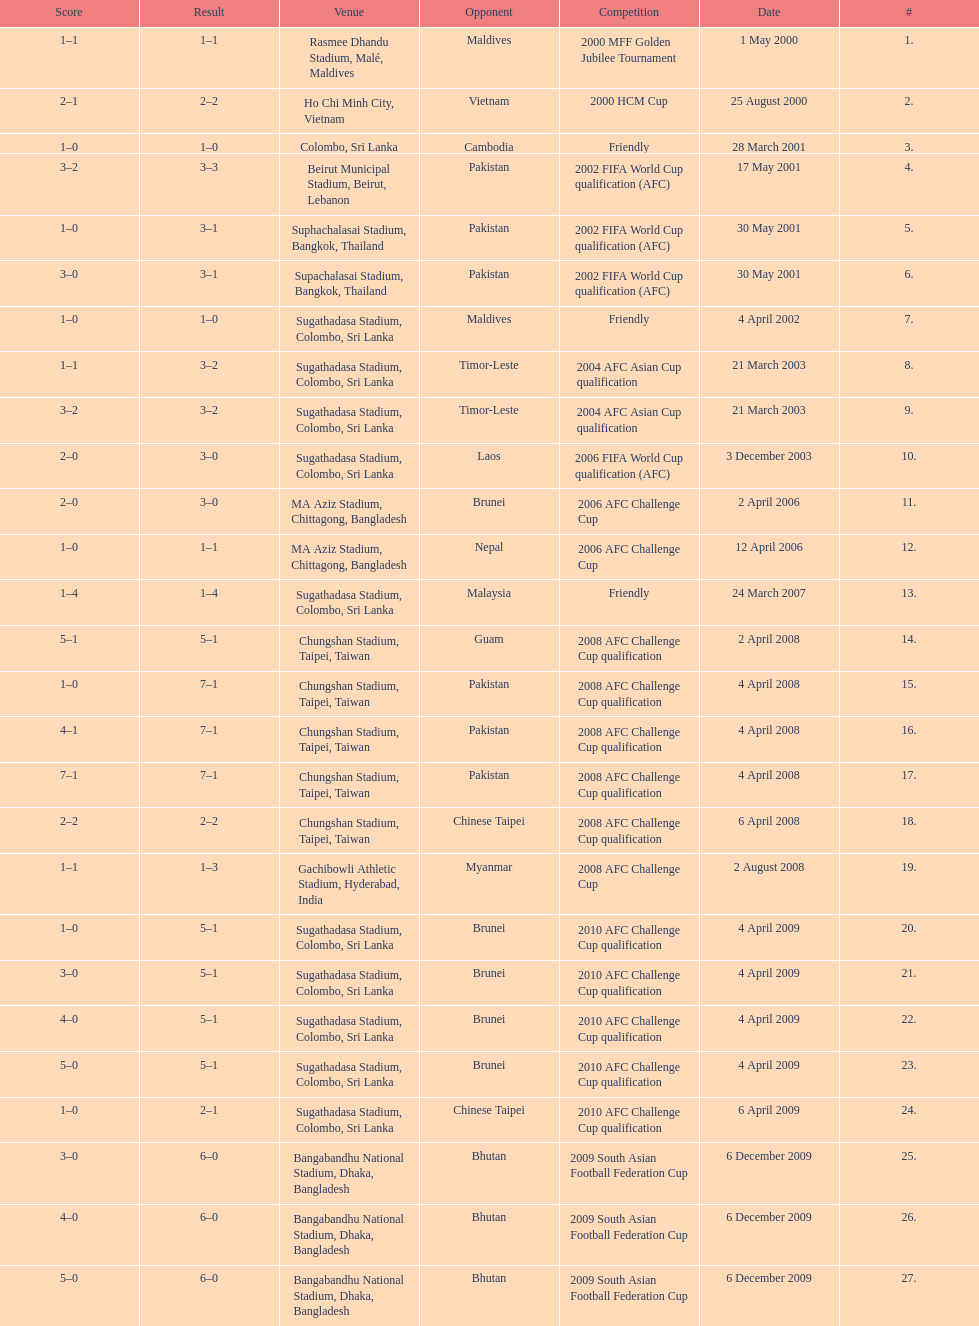What was the next venue after colombo, sri lanka on march 28? Beirut Municipal Stadium, Beirut, Lebanon. 